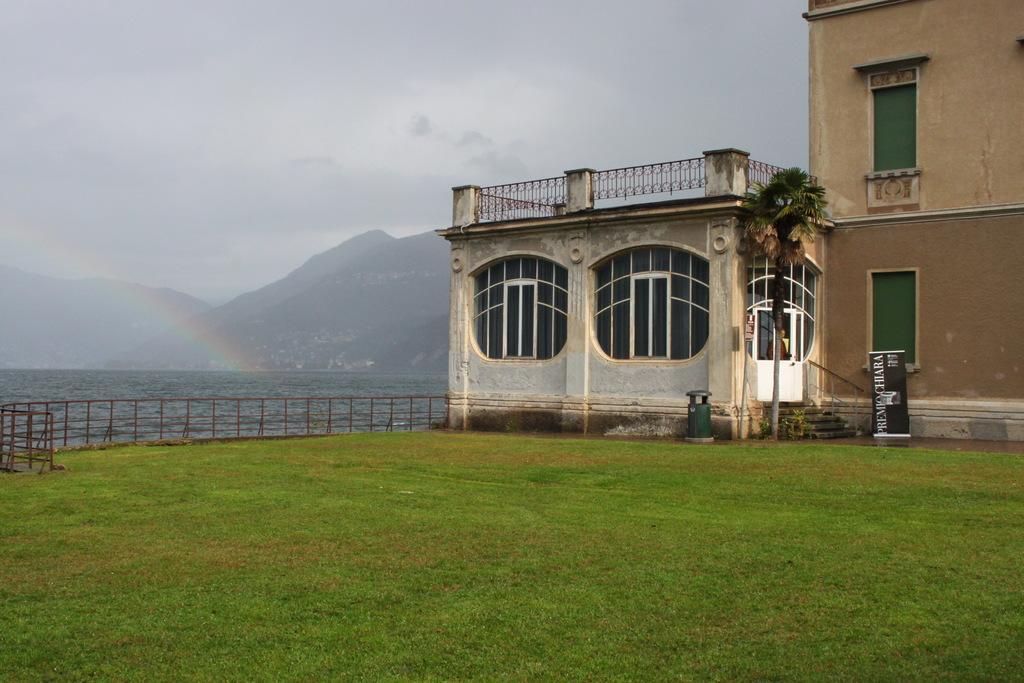Can you describe this image briefly? At the bottom of the image there is grass. In the background of the image there are mountains, buildings, water. At the top of the image there is sky. 